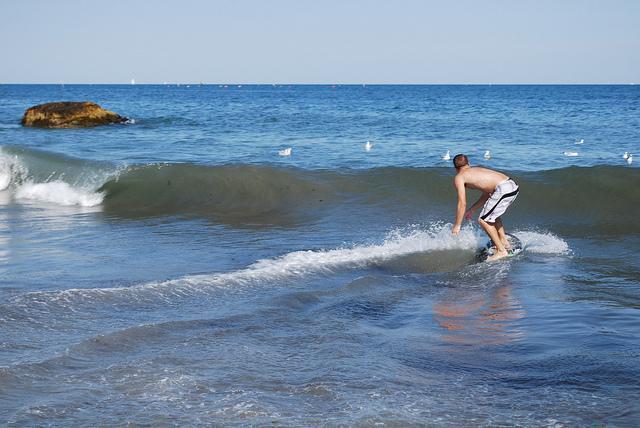Why is he crouching over?
Answer the question by selecting the correct answer among the 4 following choices.
Options: Shorter fall, stay warmer, less wind, maintain balance. Maintain balance. 